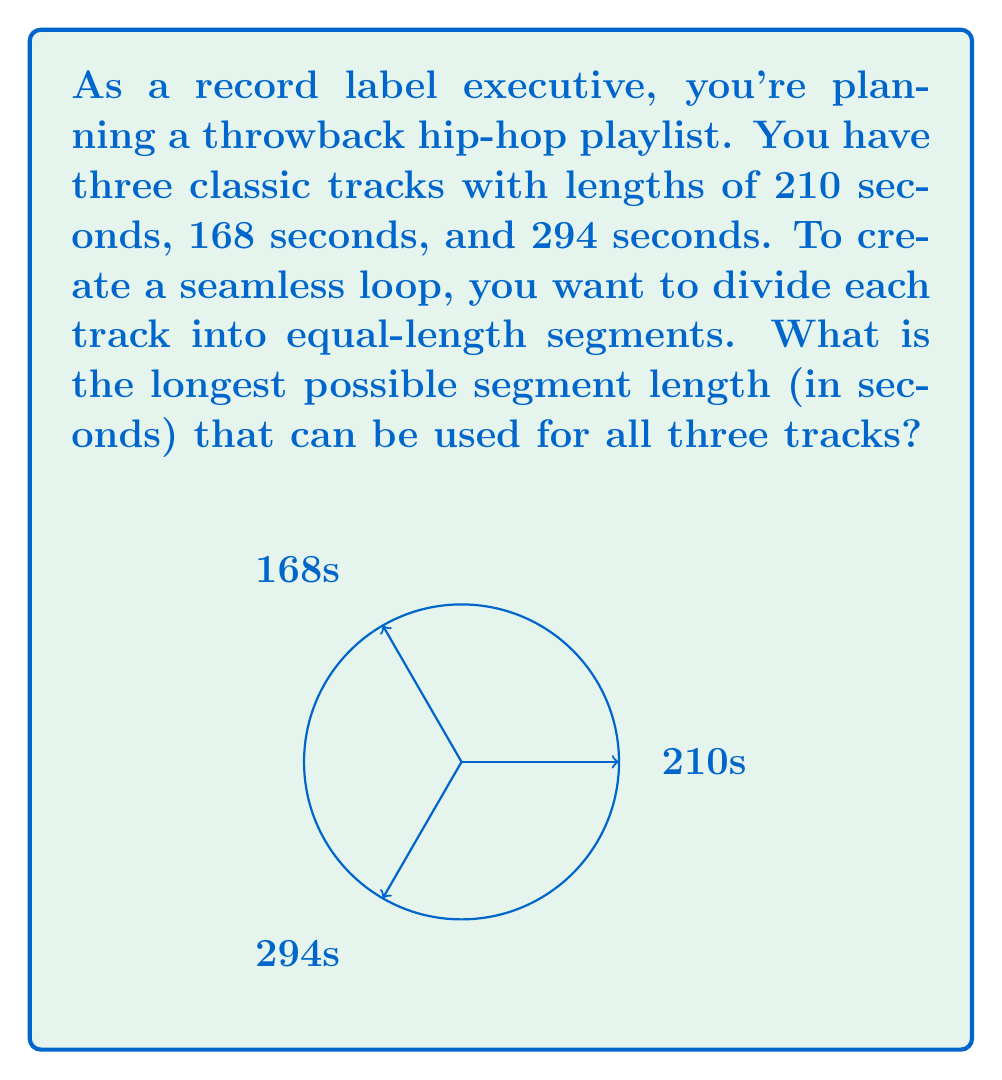Can you answer this question? To find the longest possible segment length that works for all three tracks, we need to determine the greatest common divisor (GCD) of the track lengths.

Let's use the Euclidean algorithm to find the GCD:

1) First, take the two smallest numbers: 168 and 210
   $210 = 1 \times 168 + 42$
   $168 = 4 \times 42 + 0$

   So, GCD(168, 210) = 42

2) Now, use this result with the third number: 42 and 294
   $294 = 7 \times 42 + 0$

   Therefore, GCD(42, 294) = 42

3) Since 42 is the GCD of all three numbers, it's the longest segment length that can be used for all tracks.

We can verify:
$210 \div 42 = 5$ (segments)
$168 \div 42 = 4$ (segments)
$294 \div 42 = 7$ (segments)

Thus, the longest possible segment length is 42 seconds.
Answer: 42 seconds 